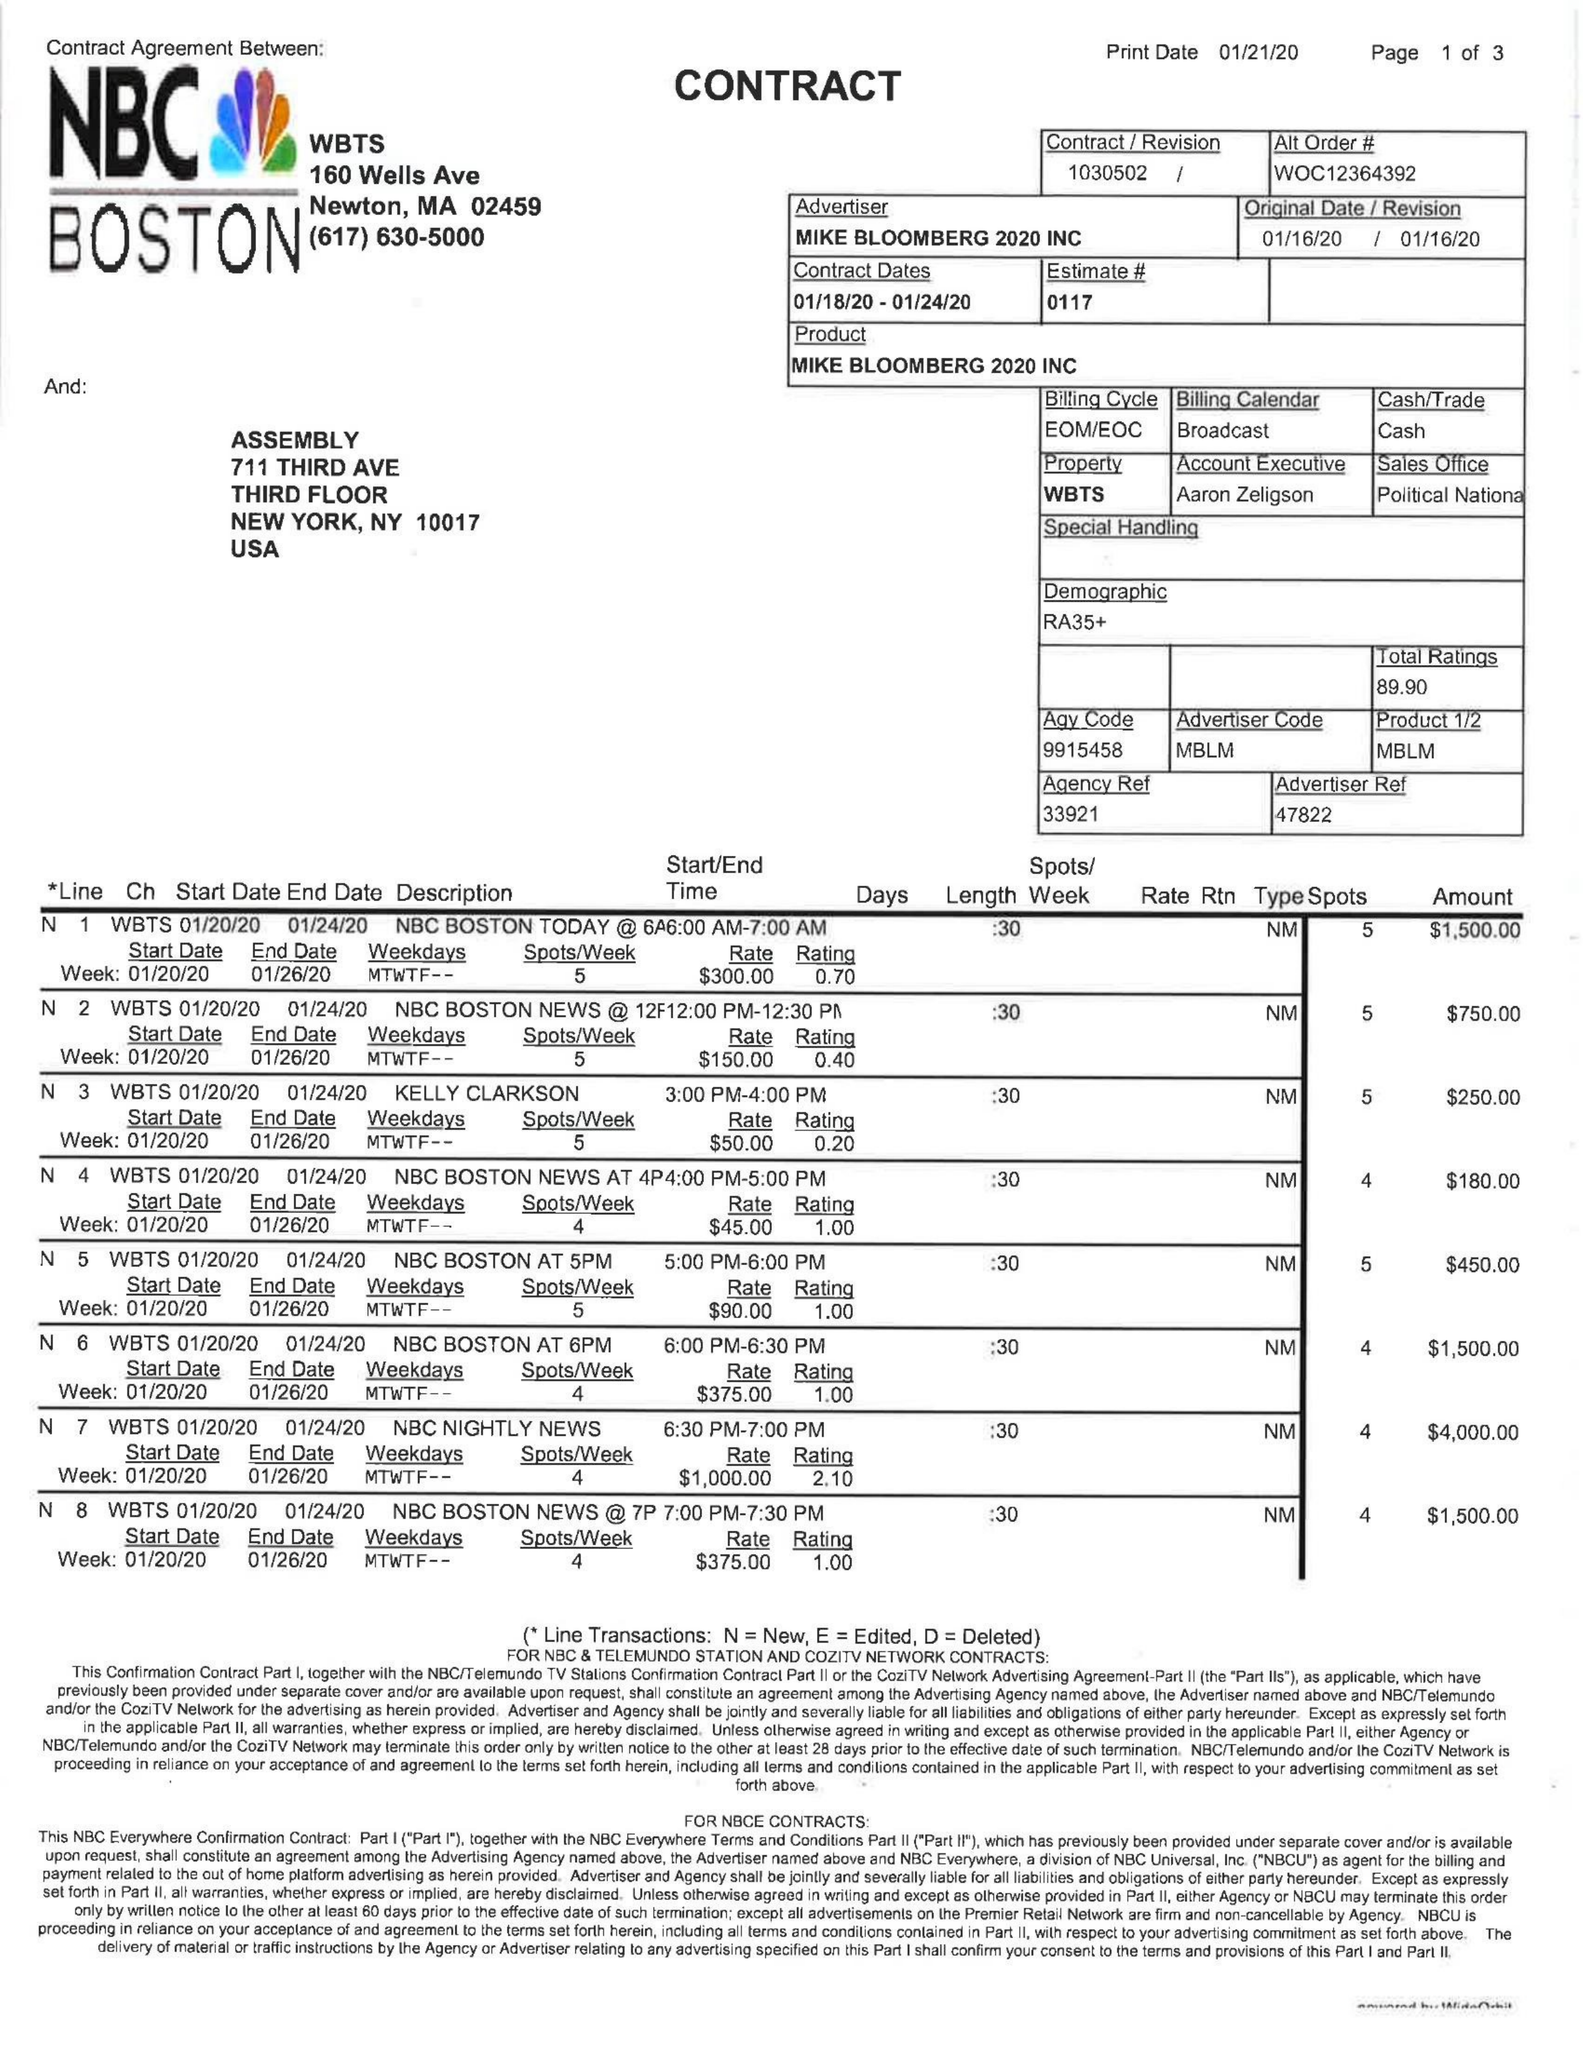What is the value for the advertiser?
Answer the question using a single word or phrase. MIKE BLOOMBERG 2020 INC 